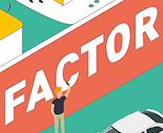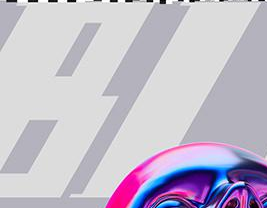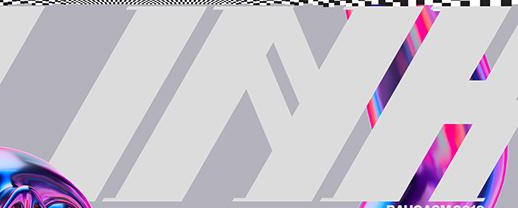What text appears in these images from left to right, separated by a semicolon? FACTOR; BI; INH 